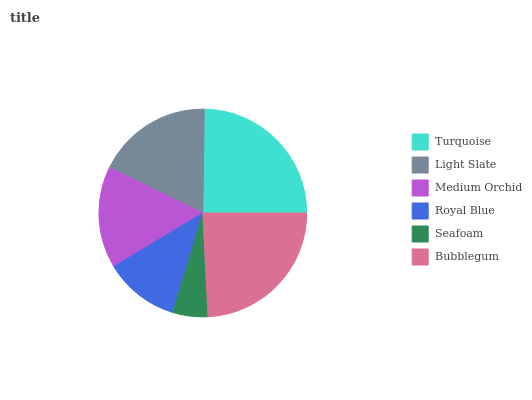Is Seafoam the minimum?
Answer yes or no. Yes. Is Turquoise the maximum?
Answer yes or no. Yes. Is Light Slate the minimum?
Answer yes or no. No. Is Light Slate the maximum?
Answer yes or no. No. Is Turquoise greater than Light Slate?
Answer yes or no. Yes. Is Light Slate less than Turquoise?
Answer yes or no. Yes. Is Light Slate greater than Turquoise?
Answer yes or no. No. Is Turquoise less than Light Slate?
Answer yes or no. No. Is Light Slate the high median?
Answer yes or no. Yes. Is Medium Orchid the low median?
Answer yes or no. Yes. Is Royal Blue the high median?
Answer yes or no. No. Is Light Slate the low median?
Answer yes or no. No. 